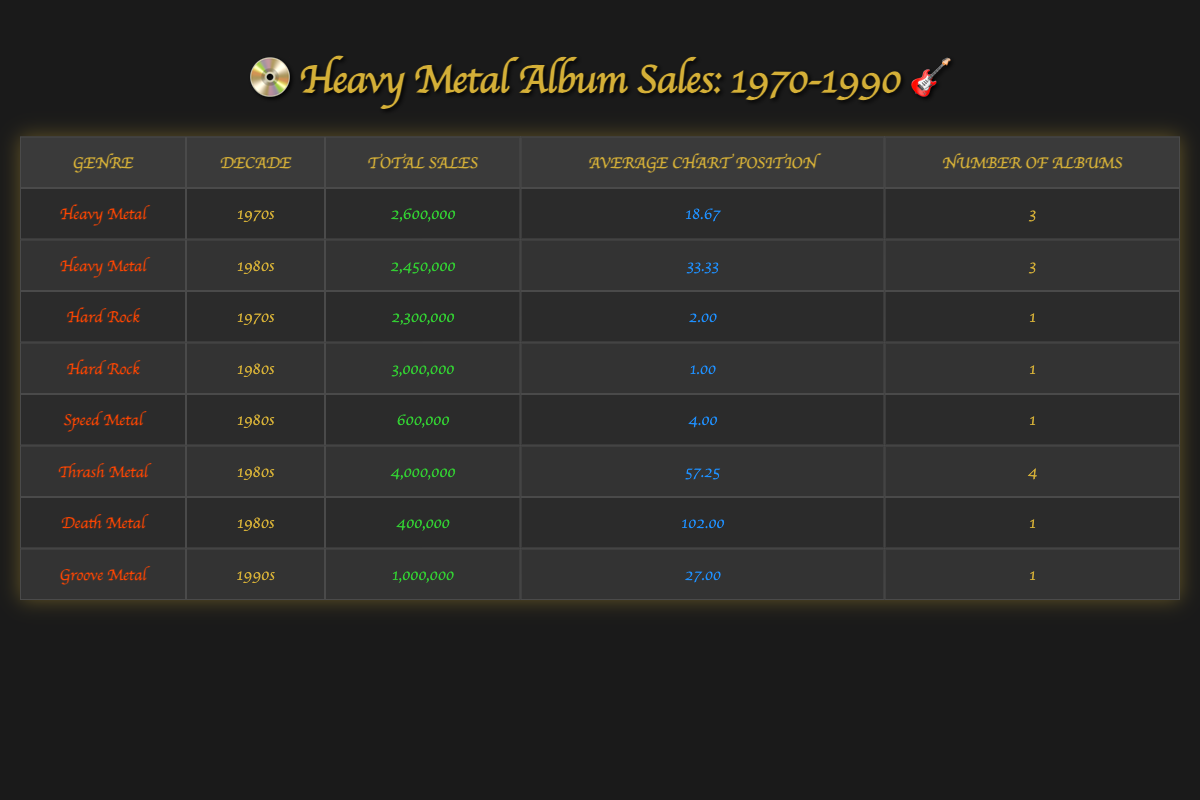What is the total sales for Heavy Metal albums in the 1970s? In the table, Heavy Metal has a total sales figure of 2,600,000 for the 1970s as indicated in the respective row.
Answer: 2,600,000 What is the average chart position for Hard Rock albums in the 1980s? There is one Hard Rock album listed for the 1980s with an average chart position of 1.00. Since there’s only one album, the average is simply 1.00.
Answer: 1.00 Did any Heavy Metal albums reach the number one position on the charts in the 1980s? In the table, it shows that the Heavy Metal album "The Number of the Beast" by Iron Maiden reached the number one position, which confirms it’s true.
Answer: Yes What are the total sales for albums labeled as Thrash Metal? Summing the sales of the four albums under the Thrash Metal genre results in a total of 4,000,000.
Answer: 4,000,000 Which genre had the highest average chart position in the 1970s? The table shows that Hard Rock had an average chart position of 2.00, while Heavy Metal has an average of 18.67. This indicates Hard Rock had the highest average chart position in the 1970s.
Answer: Hard Rock What is the difference in total sales between Heavy Metal and Hard Rock albums in the 1980s? Total sales for Heavy Metal is 2,450,000, and for Hard Rock, it is 3,000,000. The difference is calculated by subtracting Heavy Metal from Hard Rock: 3,000,000 - 2,450,000 = 550,000.
Answer: 550,000 How many albums were listed in total for the Thrash Metal genre? The table indicates that there are four albums under the Thrash Metal genre, as shown in their respective rows.
Answer: 4 What is the total sales of albums in the 1980s across all genres? Adding up the six genres listed for the 1980s gives a total of 2,450,000 (Heavy Metal) + 3,000,000 (Hard Rock) + 600,000 (Speed Metal) + 4,000,000 (Thrash Metal) + 400,000 (Death Metal) + 1,000,000 (Groove Metal) equals 11,450,000.
Answer: 11,450,000 Which decade saw the highest number of Heavy Metal albums released? The table shows that both the 1970s and 1980s each had three Heavy Metal albums listed. There are no Heavy Metal albums listed for the 1990s. Thus, both decades had the highest number.
Answer: 1970s and 1980s 